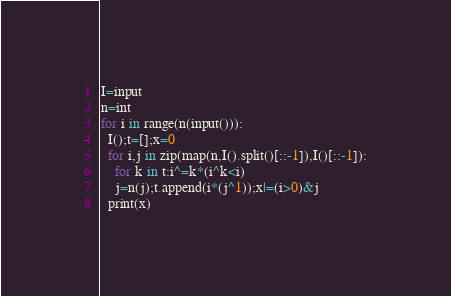Convert code to text. <code><loc_0><loc_0><loc_500><loc_500><_Python_>I=input
n=int
for i in range(n(input())):
  I();t=[];x=0
  for i,j in zip(map(n,I().split()[::-1]),I()[::-1]):
    for k in t:i^=k*(i^k<i)
    j=n(j);t.append(i*(j^1));x|=(i>0)&j
  print(x)</code> 